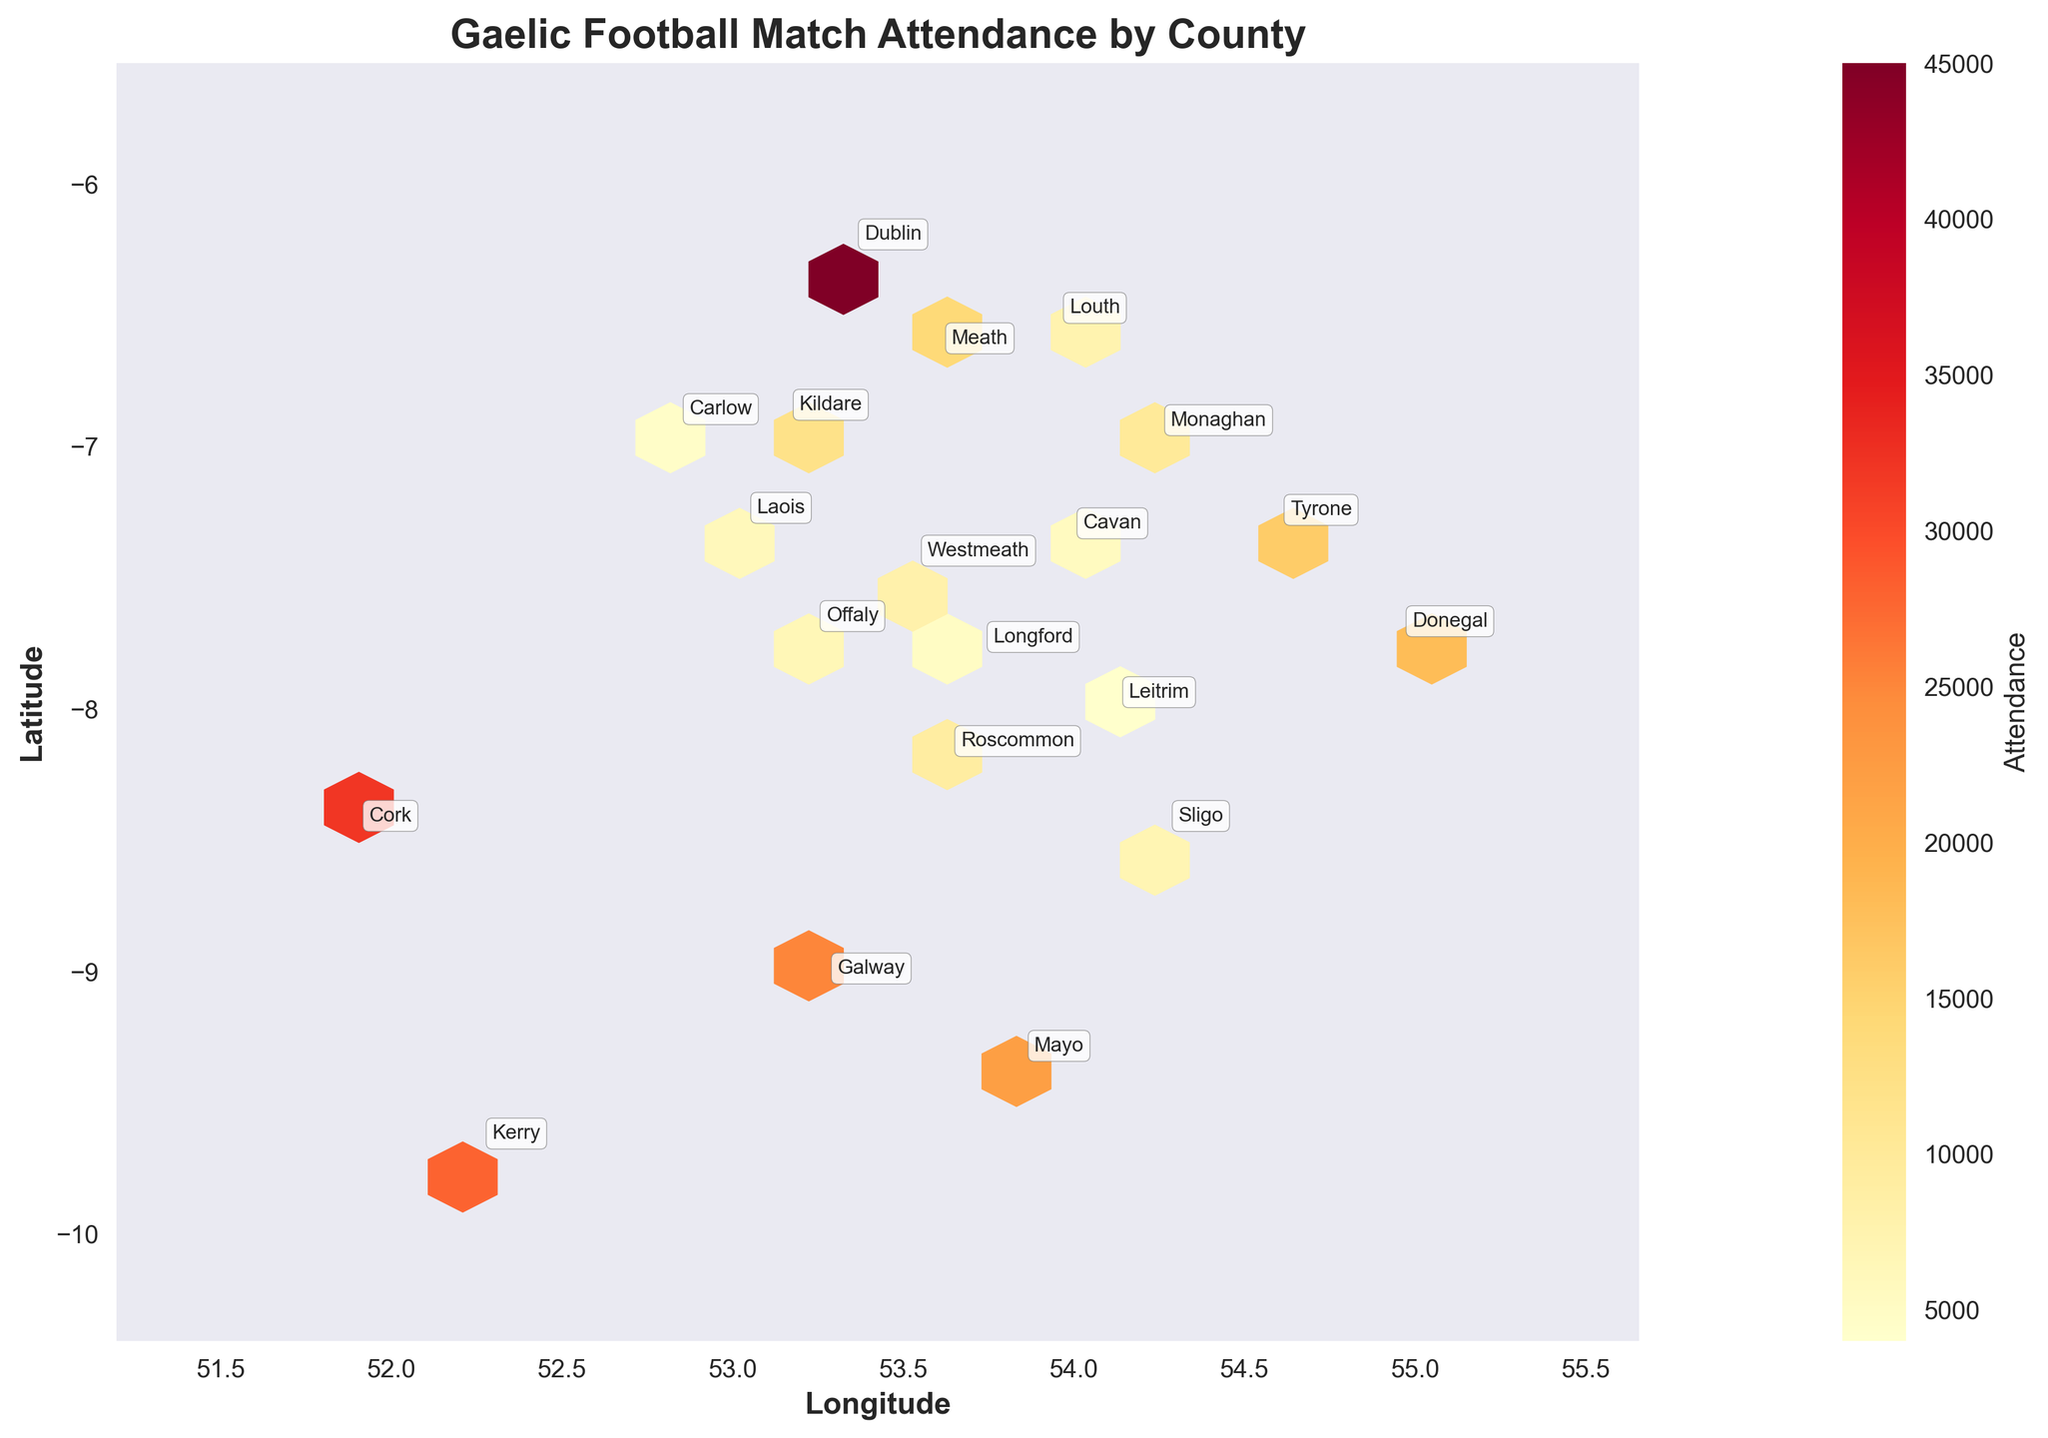What is the title of the plot? The title of the plot is typically found at the top of the figure in a larger or bold font. It summarizes the main topic or content being presented. In this case, the title is "Gaelic Football Match Attendance by County".
Answer: Gaelic Football Match Attendance by County Which county has the highest match attendance? The county with the highest match attendance can be identified by looking for the hex with the highest color intensity (darker color) and then checking the annotations. The county with a dark hex marked "Dublin" has the highest attendance.
Answer: Dublin What is the range of the color bar for Attendance? By examining the color bar on the side of the plot, we can determine the range. It shows a gradient of colors representing the range of attendance values. The color bar ranges from the minimum attendance value to the maximum attendance value.
Answer: 4000 to 45000 Which counties have match attendance below 10,000? Counties with attendance below 10,000 can be identified by lighter-colored hexes. The counties marked "Monaghan," "Roscommon," "Westmeath," "Louth," "Sligo," "Offaly," "Laois," "Cavan," "Longford," "Carlow," and "Leitrim" fall into this category.
Answer: Monaghan, Roscommon, Westmeath, Louth, Sligo, Offaly, Laois, Cavan, Longford, Carlow, Leitrim What is the color of the hex representing Cork? By cross-referencing the coordinates and annotations, we find Cork marked on the plot, and we can observe the color of the corresponding hex, which shows match attendance around 32,000. This corresponds to a specific color on the color bar.
Answer: Light orange Compare the attendance of Cork and Kerry. To compare Cork and Kerry, locate both on the plot and check the color intensity. Cork has a lighter color indicating an attendance of 32,000, while Kerry is slightly lighter with 28,000.
Answer: Cork has higher attendance than Kerry What is the average attendance in the plotted counties? To calculate the average, add the attendance values and divide by the number of counties: (45000+32000+28000+25000+22000+18000+16000+14000+12000+10000+9000+8000+7500+7000+6500+6000+5500+5000+4500+4000)/20. The sum is 294500, thus the average attendance is 294500/20.
Answer: 14725 Describe the geographic pattern of attendance in counties to the east of Ireland. Look at the counties on the right-hand side (eastern part) of the plot: Dublin, Meath, Kildare, and Louth. Dublin has very high attendance, followed by decreasing attendance values in Meath, Kildare, and Louth.
Answer: High in Dublin, decreases moving away Where is the hexbin density highest, indicating the most data points within a small area? Density is highest where hexes are more concentrated. The plot shows higher density in the central and eastern parts, centered around Dublin and its neighboring counties. These areas have more hexes closely packed.
Answer: Central and eastern counties 